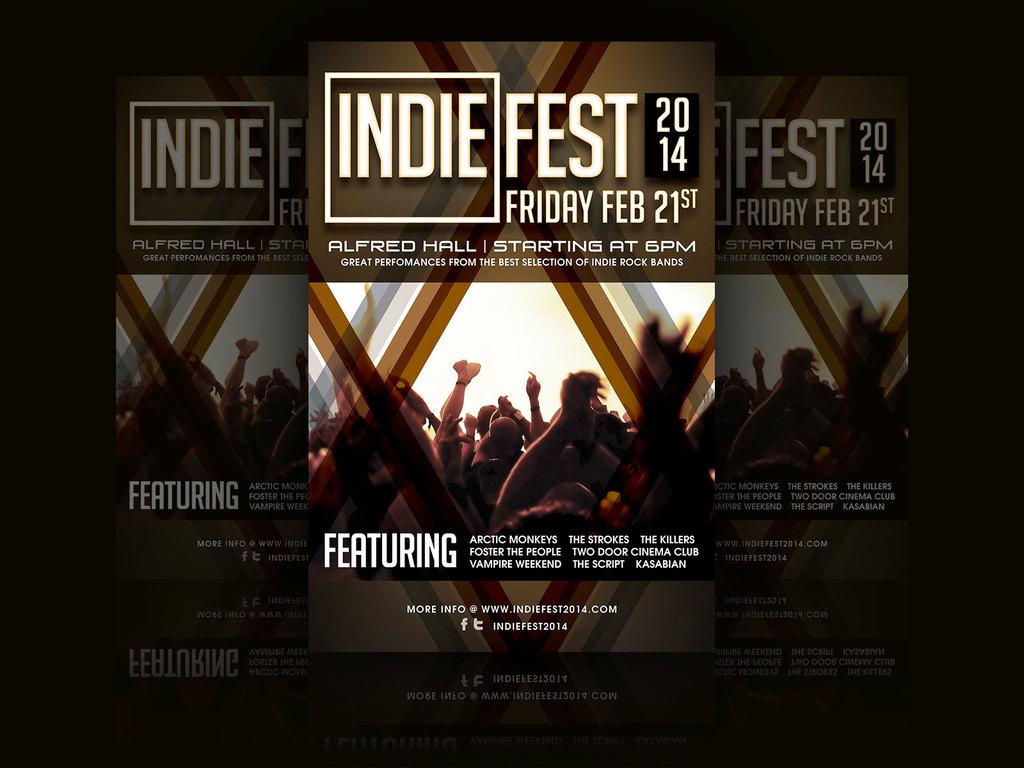When is this festival?
Ensure brevity in your answer.  Indie fest. 